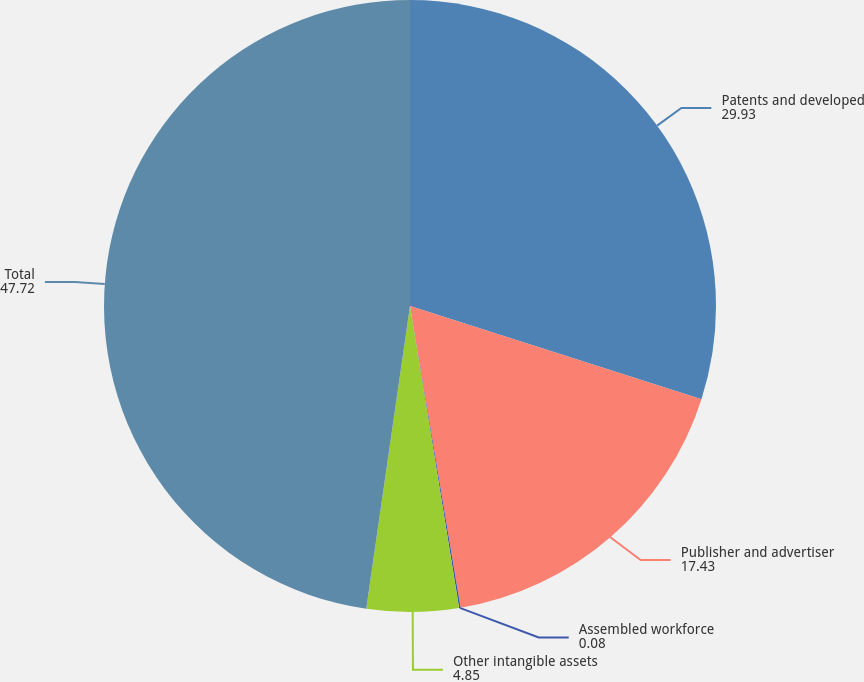<chart> <loc_0><loc_0><loc_500><loc_500><pie_chart><fcel>Patents and developed<fcel>Publisher and advertiser<fcel>Assembled workforce<fcel>Other intangible assets<fcel>Total<nl><fcel>29.93%<fcel>17.43%<fcel>0.08%<fcel>4.85%<fcel>47.72%<nl></chart> 